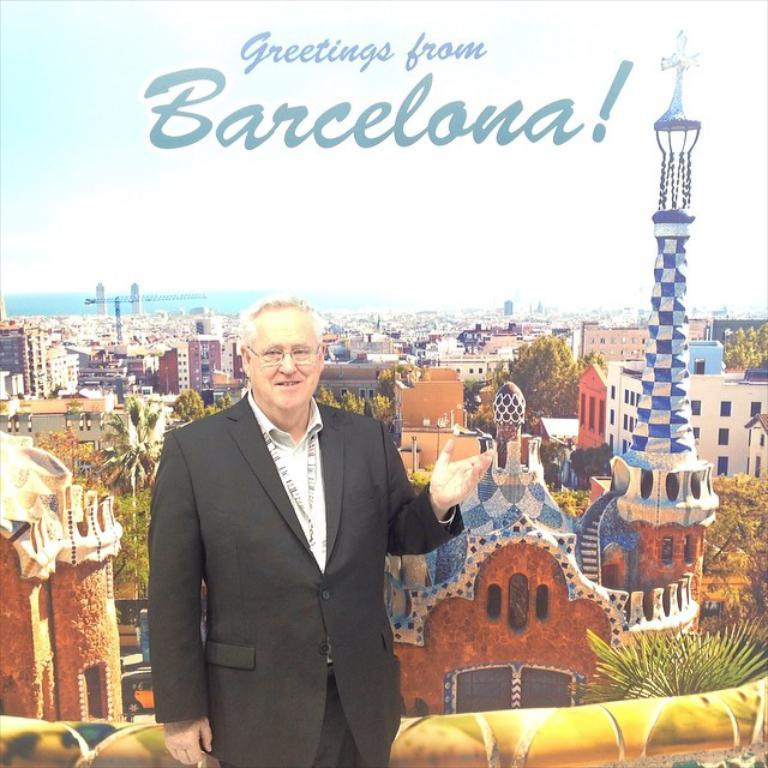Who is present in the image? There is a man in the image. What is located behind the man? There is a poster behind the man. What is depicted on the poster? The poster contains many buildings and towers. What message is displayed above the poster? There is a greeting text above the poster. Can you see a gate in the image? There is no gate present in the image. How many bees are buzzing around the man in the image? There are no bees present in the image. 